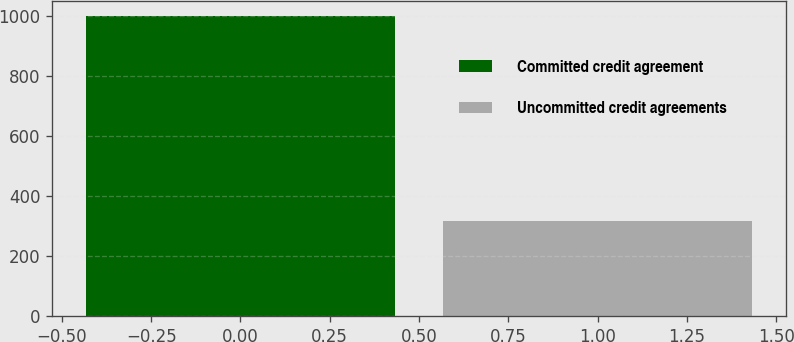<chart> <loc_0><loc_0><loc_500><loc_500><bar_chart><fcel>Committed credit agreement<fcel>Uncommitted credit agreements<nl><fcel>1000<fcel>317.2<nl></chart> 